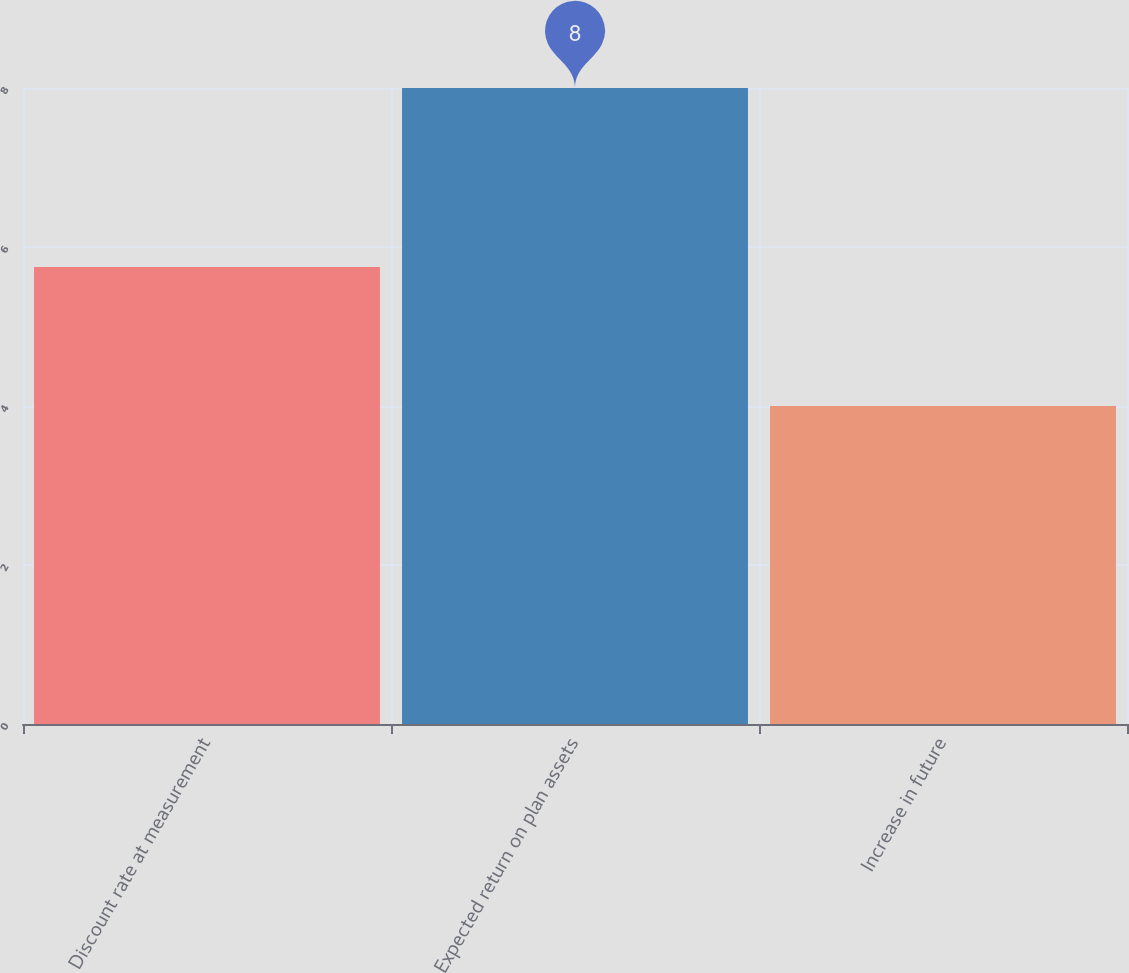Convert chart. <chart><loc_0><loc_0><loc_500><loc_500><bar_chart><fcel>Discount rate at measurement<fcel>Expected return on plan assets<fcel>Increase in future<nl><fcel>5.75<fcel>8<fcel>4<nl></chart> 